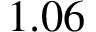Convert formula to latex. <formula><loc_0><loc_0><loc_500><loc_500>1 . 0 6</formula> 